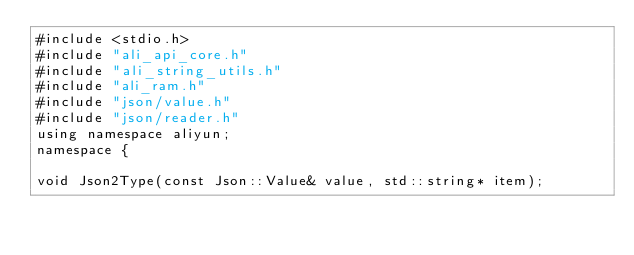<code> <loc_0><loc_0><loc_500><loc_500><_C++_>#include <stdio.h>
#include "ali_api_core.h"
#include "ali_string_utils.h"
#include "ali_ram.h"
#include "json/value.h"
#include "json/reader.h"
using namespace aliyun;
namespace {

void Json2Type(const Json::Value& value, std::string* item);</code> 